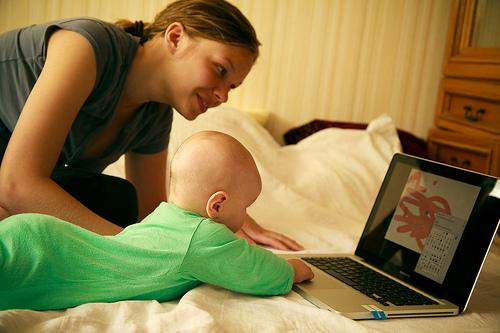What color are the sheets?
Keep it brief. White. Is the laptop on?
Write a very short answer. Yes. What color is the baby wearing?
Give a very brief answer. Green. What color shirt is the woman wearing?
Answer briefly. Gray. Does this girl have a headset on top of her head?
Concise answer only. No. What is the baby looking at?
Keep it brief. Laptop. 